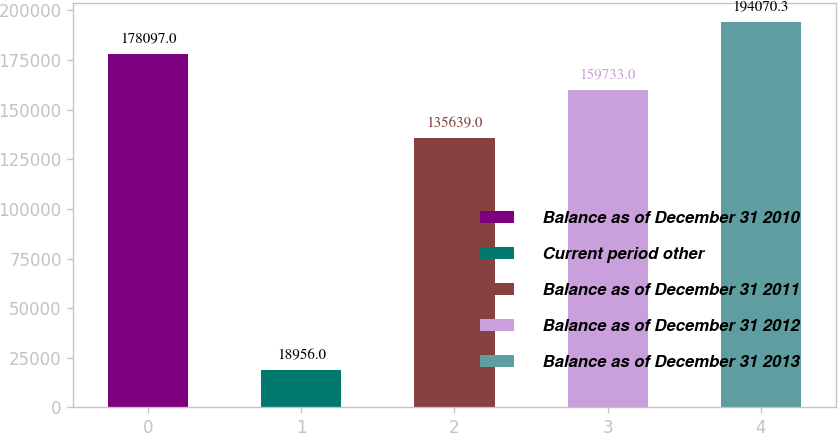Convert chart to OTSL. <chart><loc_0><loc_0><loc_500><loc_500><bar_chart><fcel>Balance as of December 31 2010<fcel>Current period other<fcel>Balance as of December 31 2011<fcel>Balance as of December 31 2012<fcel>Balance as of December 31 2013<nl><fcel>178097<fcel>18956<fcel>135639<fcel>159733<fcel>194070<nl></chart> 